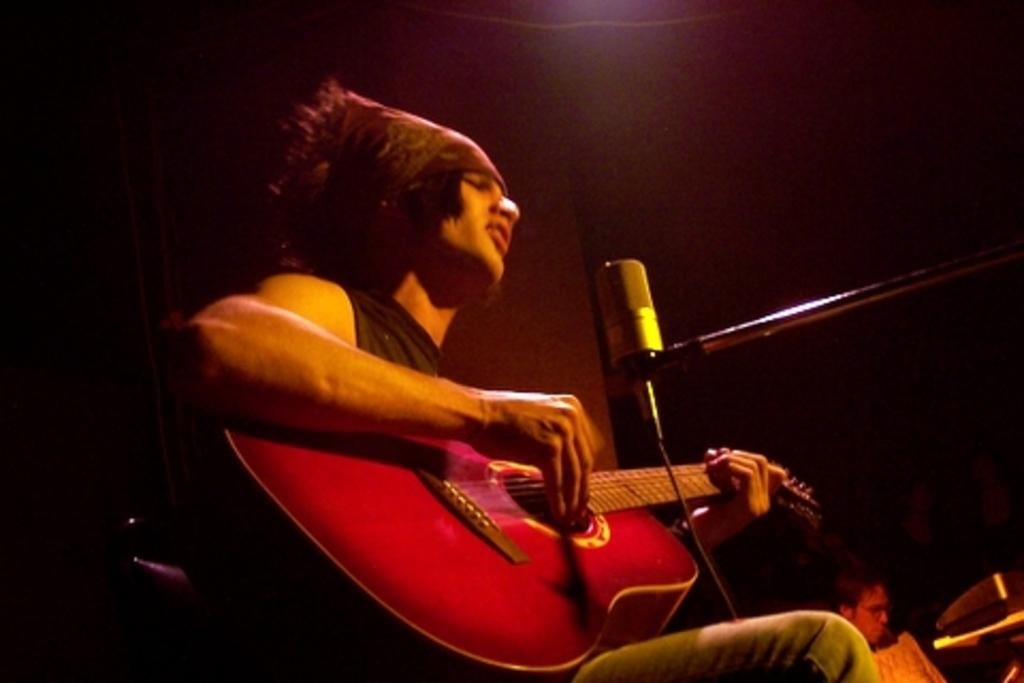What is the person in the image doing? The person in the image is playing a guitar and singing on a microphone. What instrument is the person playing in the image? The person is playing a guitar in the image. What is the person using to amplify their voice in the image? The person is using a microphone to amplify their voice in the image. What type of flower is the person holding in the image? There is no flower present in the image; the person is playing a guitar and singing on a microphone. 